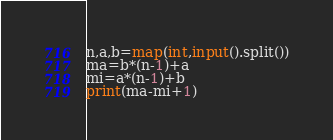<code> <loc_0><loc_0><loc_500><loc_500><_Python_>n,a,b=map(int,input().split())
ma=b*(n-1)+a
mi=a*(n-1)+b
print(ma-mi+1)
</code> 